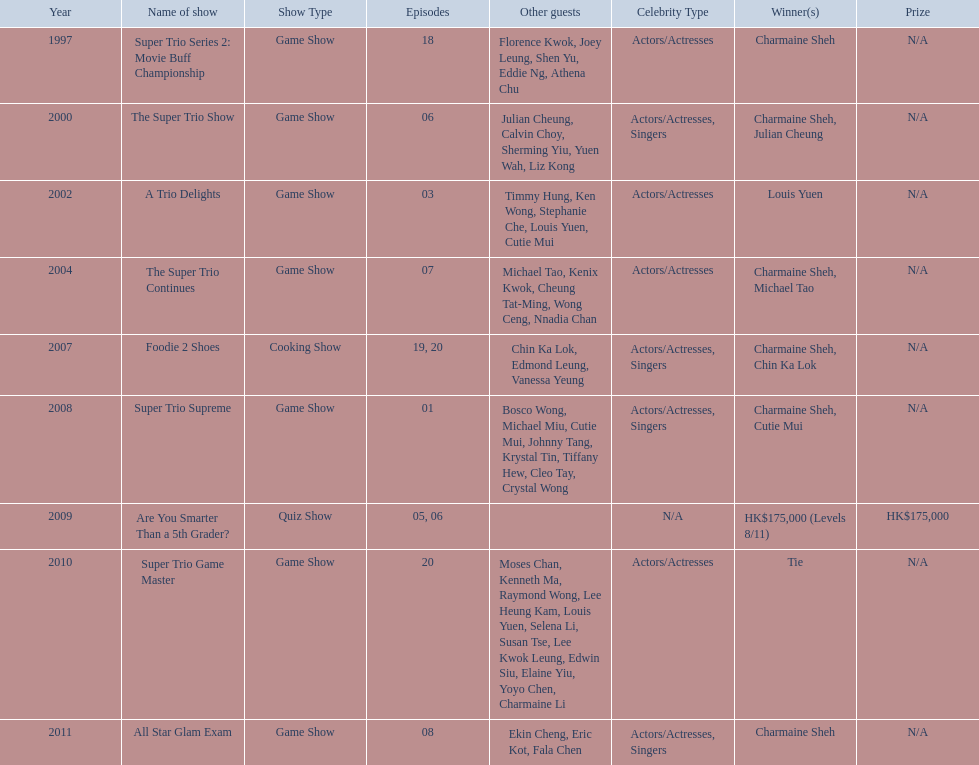Could you help me parse every detail presented in this table? {'header': ['Year', 'Name of show', 'Show Type', 'Episodes', 'Other guests', 'Celebrity Type', 'Winner(s)', 'Prize'], 'rows': [['1997', 'Super Trio Series 2: Movie Buff Championship', 'Game Show', '18', 'Florence Kwok, Joey Leung, Shen Yu, Eddie Ng, Athena Chu', 'Actors/Actresses', 'Charmaine Sheh', 'N/A'], ['2000', 'The Super Trio Show', 'Game Show', '06', 'Julian Cheung, Calvin Choy, Sherming Yiu, Yuen Wah, Liz Kong', 'Actors/Actresses, Singers', 'Charmaine Sheh, Julian Cheung', 'N/A'], ['2002', 'A Trio Delights', 'Game Show', '03', 'Timmy Hung, Ken Wong, Stephanie Che, Louis Yuen, Cutie Mui', 'Actors/Actresses', 'Louis Yuen', 'N/A'], ['2004', 'The Super Trio Continues', 'Game Show', '07', 'Michael Tao, Kenix Kwok, Cheung Tat-Ming, Wong Ceng, Nnadia Chan', 'Actors/Actresses', 'Charmaine Sheh, Michael Tao', 'N/A'], ['2007', 'Foodie 2 Shoes', 'Cooking Show', '19, 20', 'Chin Ka Lok, Edmond Leung, Vanessa Yeung', 'Actors/Actresses, Singers', 'Charmaine Sheh, Chin Ka Lok', 'N/A'], ['2008', 'Super Trio Supreme', 'Game Show', '01', 'Bosco Wong, Michael Miu, Cutie Mui, Johnny Tang, Krystal Tin, Tiffany Hew, Cleo Tay, Crystal Wong', 'Actors/Actresses, Singers', 'Charmaine Sheh, Cutie Mui', 'N/A'], ['2009', 'Are You Smarter Than a 5th Grader?', 'Quiz Show', '05, 06', '', 'N/A', 'HK$175,000 (Levels 8/11)', 'HK$175,000'], ['2010', 'Super Trio Game Master', 'Game Show', '20', 'Moses Chan, Kenneth Ma, Raymond Wong, Lee Heung Kam, Louis Yuen, Selena Li, Susan Tse, Lee Kwok Leung, Edwin Siu, Elaine Yiu, Yoyo Chen, Charmaine Li', 'Actors/Actresses', 'Tie', 'N/A'], ['2011', 'All Star Glam Exam', 'Game Show', '08', 'Ekin Cheng, Eric Kot, Fala Chen', 'Actors/Actresses, Singers', 'Charmaine Sheh', 'N/A']]} For the super trio 2: movie buff champions variety show, how many episodes included charmaine sheh's participation? 18. 